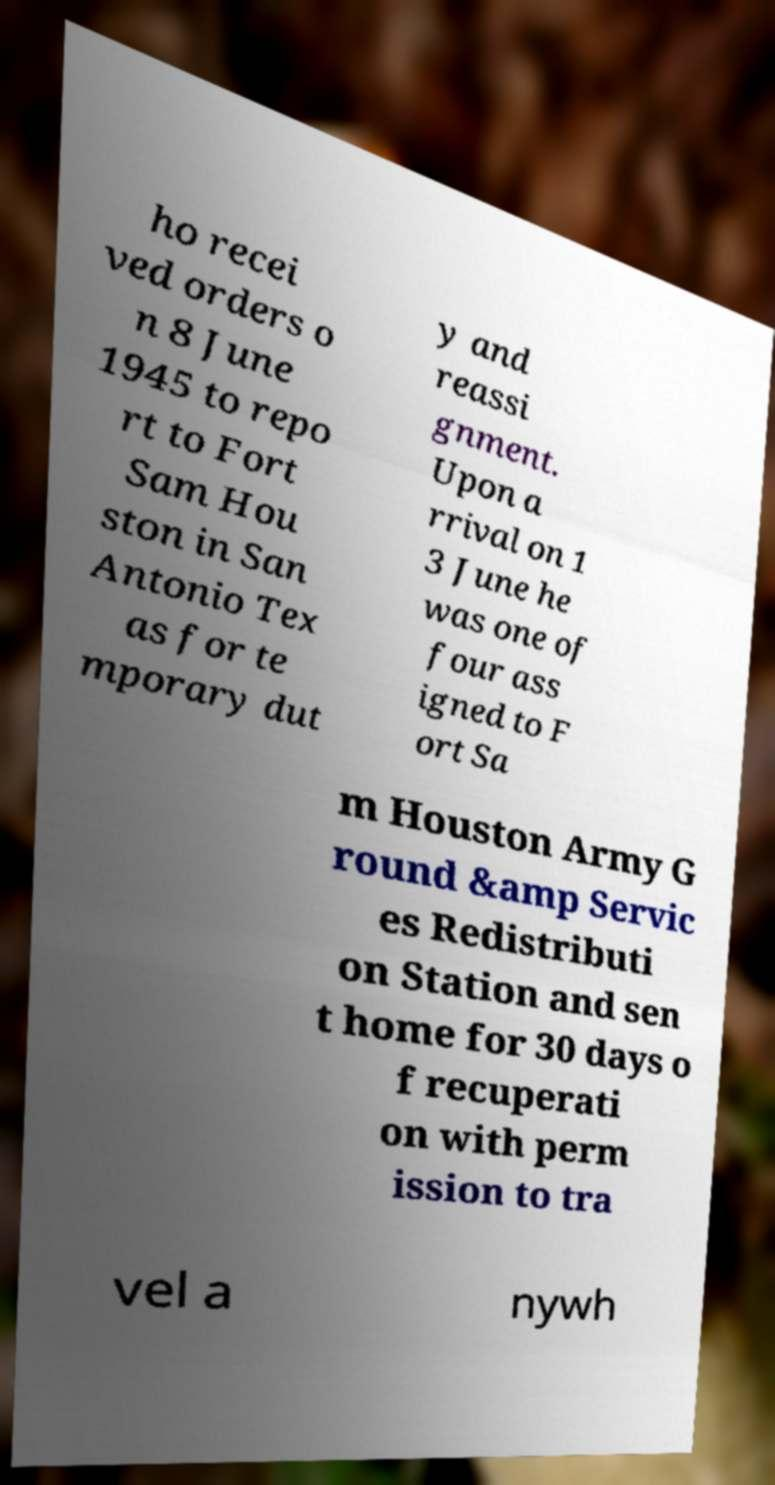Can you accurately transcribe the text from the provided image for me? ho recei ved orders o n 8 June 1945 to repo rt to Fort Sam Hou ston in San Antonio Tex as for te mporary dut y and reassi gnment. Upon a rrival on 1 3 June he was one of four ass igned to F ort Sa m Houston Army G round &amp Servic es Redistributi on Station and sen t home for 30 days o f recuperati on with perm ission to tra vel a nywh 